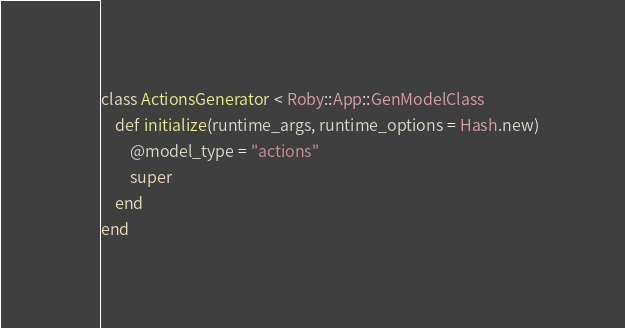<code> <loc_0><loc_0><loc_500><loc_500><_Ruby_>class ActionsGenerator < Roby::App::GenModelClass
    def initialize(runtime_args, runtime_options = Hash.new)
        @model_type = "actions"
        super
    end
end

</code> 